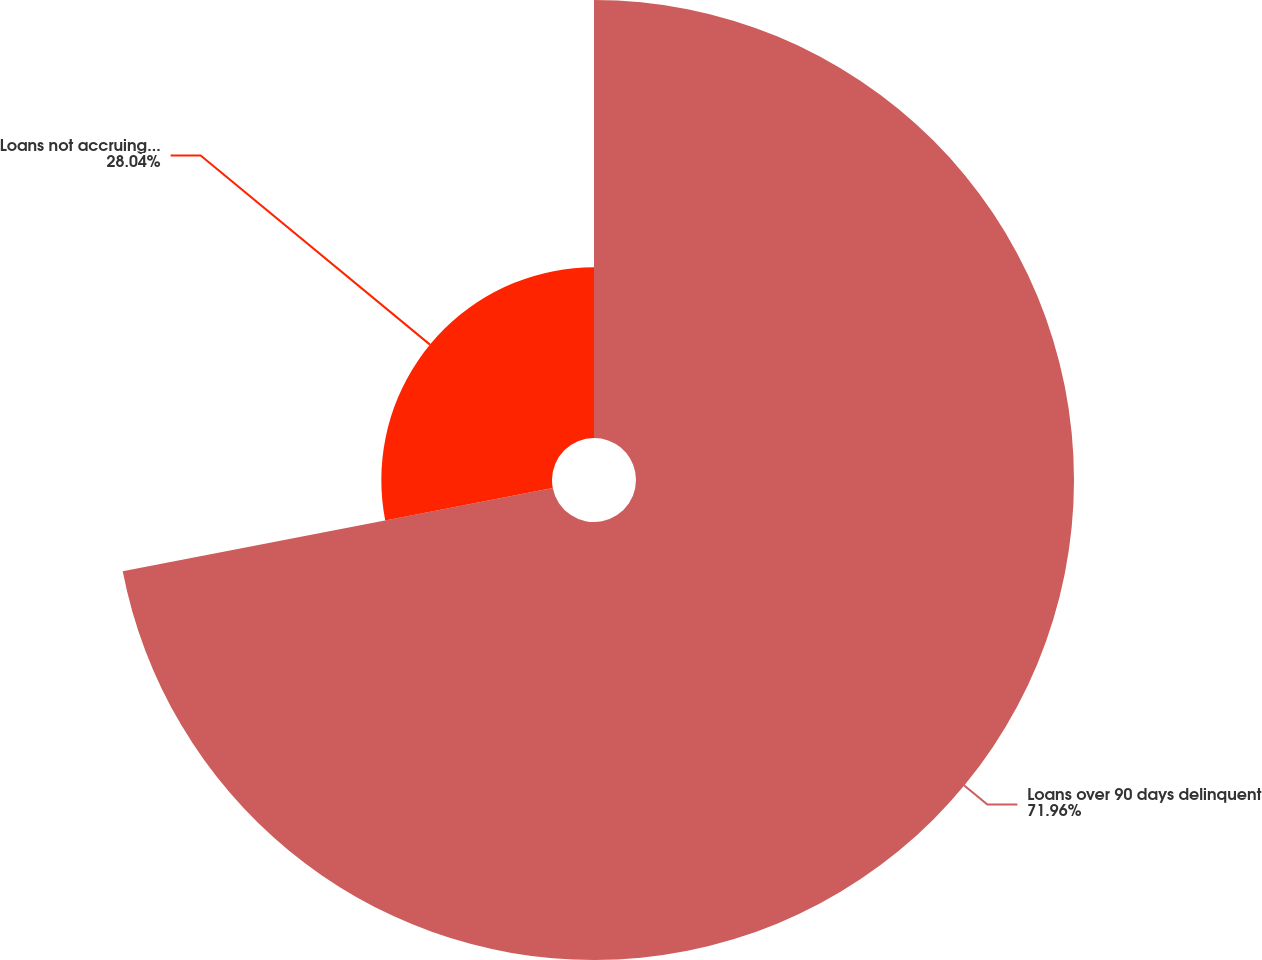Convert chart. <chart><loc_0><loc_0><loc_500><loc_500><pie_chart><fcel>Loans over 90 days delinquent<fcel>Loans not accruing interest<nl><fcel>71.96%<fcel>28.04%<nl></chart> 